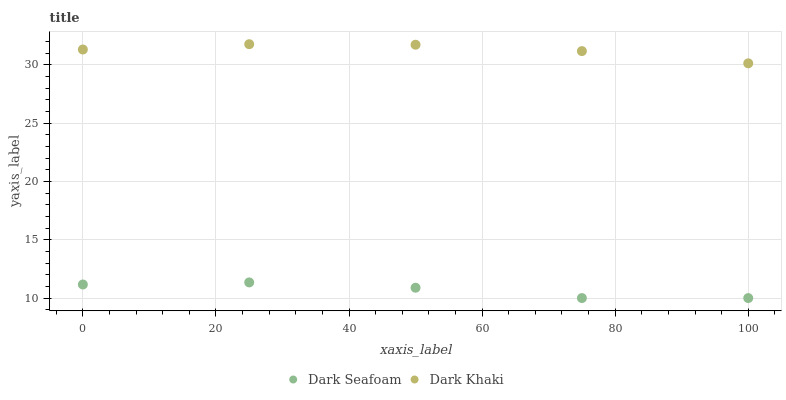Does Dark Seafoam have the minimum area under the curve?
Answer yes or no. Yes. Does Dark Khaki have the maximum area under the curve?
Answer yes or no. Yes. Does Dark Seafoam have the maximum area under the curve?
Answer yes or no. No. Is Dark Khaki the smoothest?
Answer yes or no. Yes. Is Dark Seafoam the roughest?
Answer yes or no. Yes. Is Dark Seafoam the smoothest?
Answer yes or no. No. Does Dark Seafoam have the lowest value?
Answer yes or no. Yes. Does Dark Khaki have the highest value?
Answer yes or no. Yes. Does Dark Seafoam have the highest value?
Answer yes or no. No. Is Dark Seafoam less than Dark Khaki?
Answer yes or no. Yes. Is Dark Khaki greater than Dark Seafoam?
Answer yes or no. Yes. Does Dark Seafoam intersect Dark Khaki?
Answer yes or no. No. 